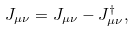Convert formula to latex. <formula><loc_0><loc_0><loc_500><loc_500>J _ { \mu \nu } = J _ { \mu \nu } - J _ { \mu \nu } ^ { \dagger } ,</formula> 